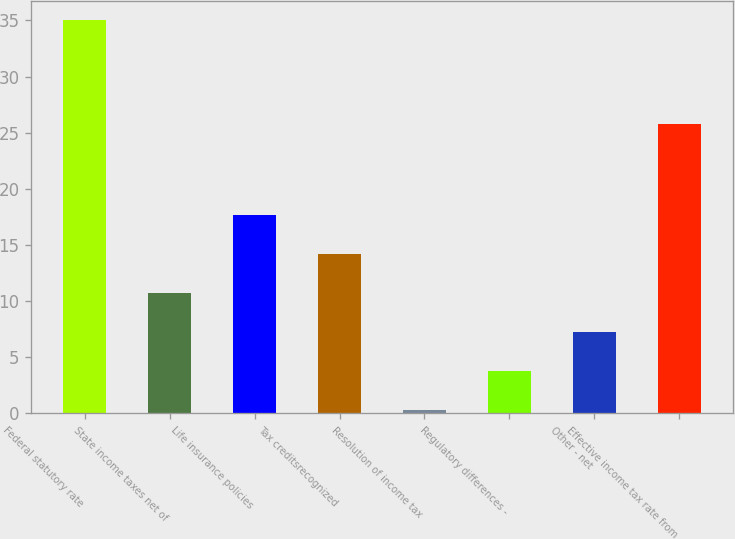<chart> <loc_0><loc_0><loc_500><loc_500><bar_chart><fcel>Federal statutory rate<fcel>State income taxes net of<fcel>Life insurance policies<fcel>Tax creditsrecognized<fcel>Resolution of income tax<fcel>Regulatory differences -<fcel>Other - net<fcel>Effective income tax rate from<nl><fcel>35<fcel>10.71<fcel>17.65<fcel>14.18<fcel>0.3<fcel>3.77<fcel>7.24<fcel>25.8<nl></chart> 